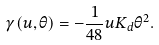Convert formula to latex. <formula><loc_0><loc_0><loc_500><loc_500>\gamma ( u , \theta ) = - \frac { 1 } { 4 8 } u K _ { d } \theta ^ { 2 } .</formula> 